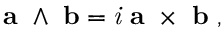<formula> <loc_0><loc_0><loc_500><loc_500>a \ \wedge \ b = { i } \ a \ \times \ b \ ,</formula> 